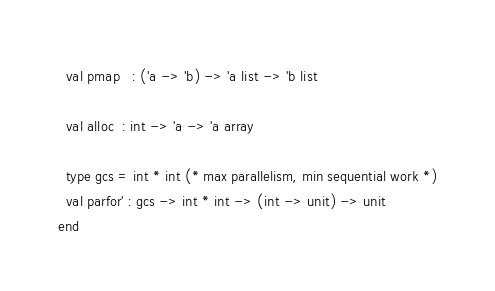<code> <loc_0><loc_0><loc_500><loc_500><_SML_>  val pmap   : ('a -> 'b) -> 'a list -> 'b list

  val alloc  : int -> 'a -> 'a array

  type gcs = int * int (* max parallelism, min sequential work *)
  val parfor' : gcs -> int * int -> (int -> unit) -> unit
end
</code> 